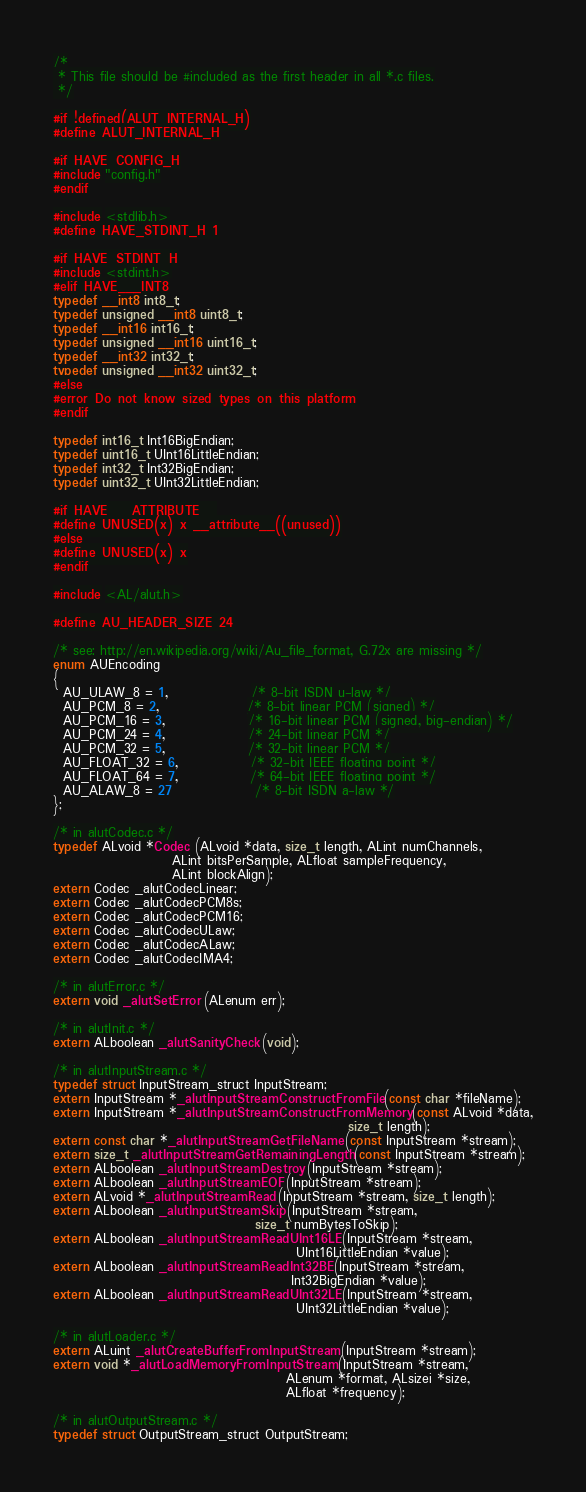Convert code to text. <code><loc_0><loc_0><loc_500><loc_500><_C_>/*
 * This file should be #included as the first header in all *.c files.
 */

#if !defined(ALUT_INTERNAL_H)
#define ALUT_INTERNAL_H

#if HAVE_CONFIG_H
#include "config.h"
#endif

#include <stdlib.h>
#define HAVE_STDINT_H 1

#if HAVE_STDINT_H
#include <stdint.h>
#elif HAVE___INT8
typedef __int8 int8_t;
typedef unsigned __int8 uint8_t;
typedef __int16 int16_t;
typedef unsigned __int16 uint16_t;
typedef __int32 int32_t;
typedef unsigned __int32 uint32_t;
#else
#error Do not know sized types on this platform
#endif

typedef int16_t Int16BigEndian;
typedef uint16_t UInt16LittleEndian;
typedef int32_t Int32BigEndian;
typedef uint32_t UInt32LittleEndian;

#if HAVE___ATTRIBUTE__
#define UNUSED(x) x __attribute__((unused))
#else
#define UNUSED(x) x
#endif

#include <AL/alut.h>

#define AU_HEADER_SIZE 24

/* see: http://en.wikipedia.org/wiki/Au_file_format, G.72x are missing */
enum AUEncoding
{
  AU_ULAW_8 = 1,                /* 8-bit ISDN u-law */
  AU_PCM_8 = 2,                 /* 8-bit linear PCM (signed) */
  AU_PCM_16 = 3,                /* 16-bit linear PCM (signed, big-endian) */
  AU_PCM_24 = 4,                /* 24-bit linear PCM */
  AU_PCM_32 = 5,                /* 32-bit linear PCM */
  AU_FLOAT_32 = 6,              /* 32-bit IEEE floating point */
  AU_FLOAT_64 = 7,              /* 64-bit IEEE floating point */
  AU_ALAW_8 = 27                /* 8-bit ISDN a-law */
};

/* in alutCodec.c */
typedef ALvoid *Codec (ALvoid *data, size_t length, ALint numChannels,
                       ALint bitsPerSample, ALfloat sampleFrequency,
                       ALint blockAlign);
extern Codec _alutCodecLinear;
extern Codec _alutCodecPCM8s;
extern Codec _alutCodecPCM16;
extern Codec _alutCodecULaw;
extern Codec _alutCodecALaw;
extern Codec _alutCodecIMA4;

/* in alutError.c */
extern void _alutSetError (ALenum err);

/* in alutInit.c */
extern ALboolean _alutSanityCheck (void);

/* in alutInputStream.c */
typedef struct InputStream_struct InputStream;
extern InputStream *_alutInputStreamConstructFromFile (const char *fileName);
extern InputStream *_alutInputStreamConstructFromMemory (const ALvoid *data,
                                                         size_t length);
extern const char *_alutInputStreamGetFileName (const InputStream *stream);
extern size_t _alutInputStreamGetRemainingLength (const InputStream *stream);
extern ALboolean _alutInputStreamDestroy (InputStream *stream);
extern ALboolean _alutInputStreamEOF (InputStream *stream);
extern ALvoid *_alutInputStreamRead (InputStream *stream, size_t length);
extern ALboolean _alutInputStreamSkip (InputStream *stream,
                                       size_t numBytesToSkip);
extern ALboolean _alutInputStreamReadUInt16LE (InputStream *stream,
                                               UInt16LittleEndian *value);
extern ALboolean _alutInputStreamReadInt32BE (InputStream *stream,
                                              Int32BigEndian *value);
extern ALboolean _alutInputStreamReadUInt32LE (InputStream *stream,
                                               UInt32LittleEndian *value);

/* in alutLoader.c */
extern ALuint _alutCreateBufferFromInputStream (InputStream *stream);
extern void *_alutLoadMemoryFromInputStream (InputStream *stream,
                                             ALenum *format, ALsizei *size,
                                             ALfloat *frequency);

/* in alutOutputStream.c */
typedef struct OutputStream_struct OutputStream;</code> 